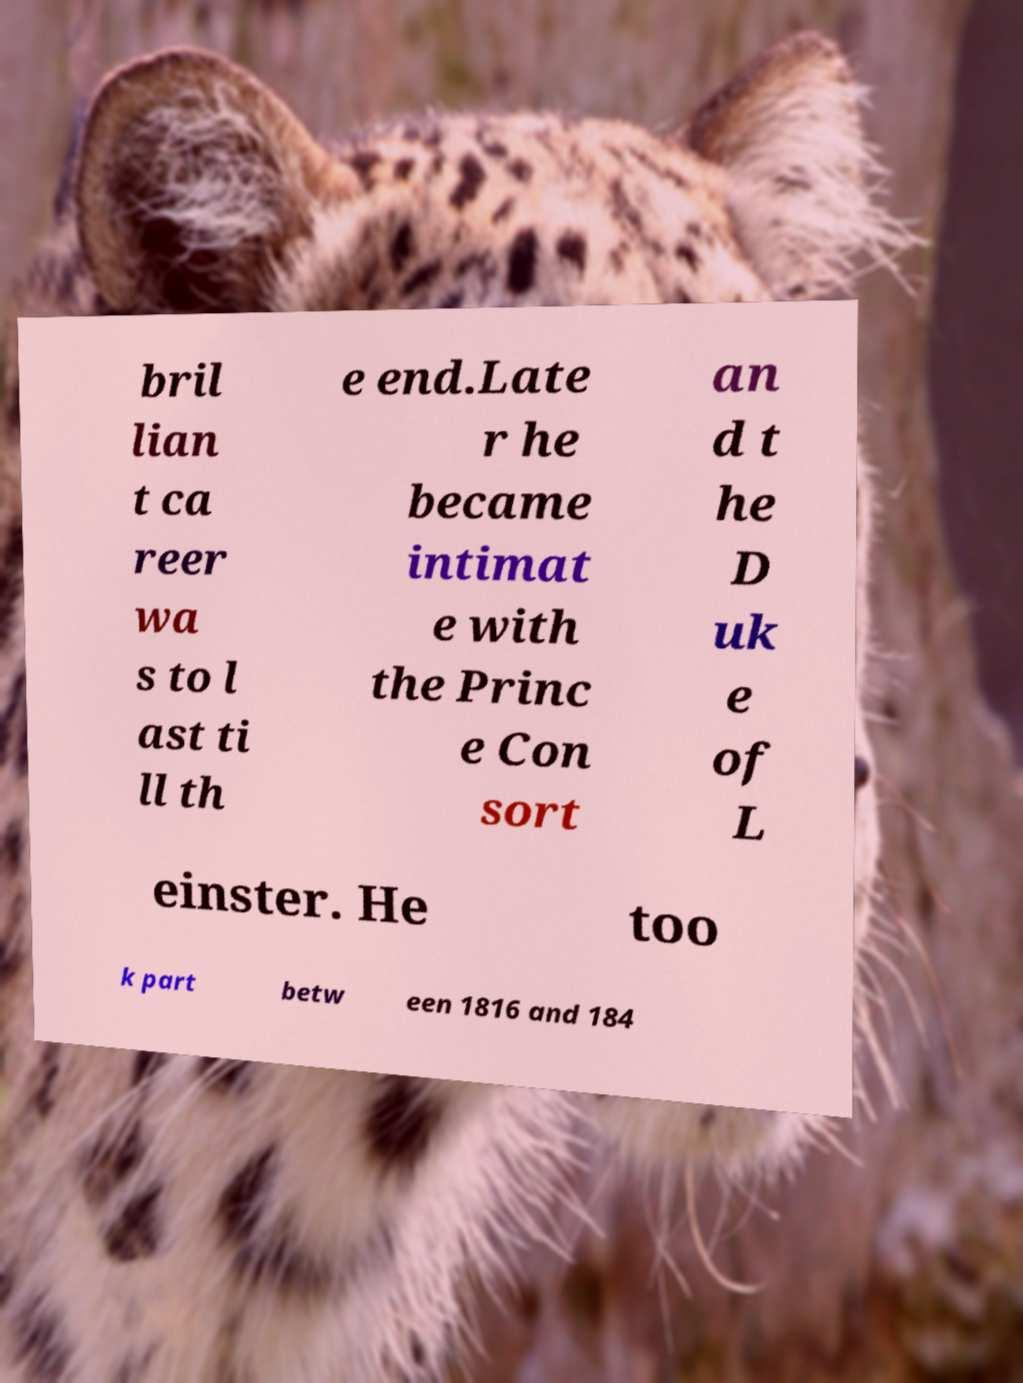Please identify and transcribe the text found in this image. bril lian t ca reer wa s to l ast ti ll th e end.Late r he became intimat e with the Princ e Con sort an d t he D uk e of L einster. He too k part betw een 1816 and 184 